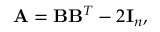<formula> <loc_0><loc_0><loc_500><loc_500>{ A } = { B } { B } ^ { T } - 2 { I } _ { n } ,</formula> 